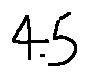Convert formula to latex. <formula><loc_0><loc_0><loc_500><loc_500>4 . 5</formula> 